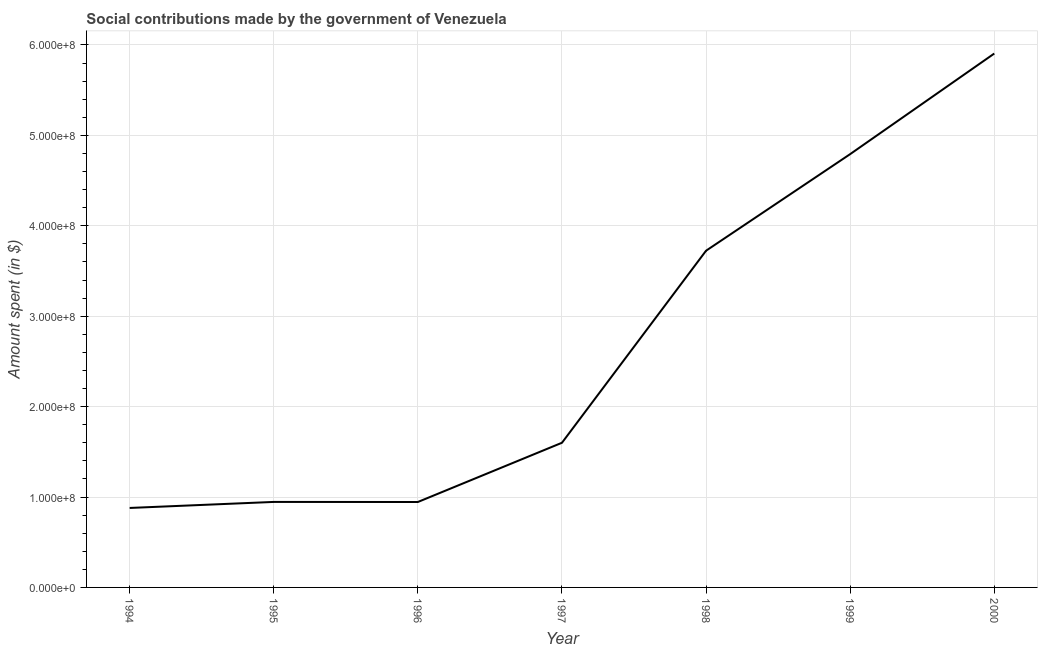What is the amount spent in making social contributions in 1998?
Offer a terse response. 3.72e+08. Across all years, what is the maximum amount spent in making social contributions?
Give a very brief answer. 5.91e+08. Across all years, what is the minimum amount spent in making social contributions?
Your answer should be compact. 8.79e+07. What is the sum of the amount spent in making social contributions?
Offer a very short reply. 1.88e+09. What is the difference between the amount spent in making social contributions in 1994 and 1998?
Give a very brief answer. -2.85e+08. What is the average amount spent in making social contributions per year?
Keep it short and to the point. 2.68e+08. What is the median amount spent in making social contributions?
Give a very brief answer. 1.60e+08. In how many years, is the amount spent in making social contributions greater than 100000000 $?
Your answer should be very brief. 4. Do a majority of the years between 1996 and 1997 (inclusive) have amount spent in making social contributions greater than 500000000 $?
Make the answer very short. No. What is the ratio of the amount spent in making social contributions in 1995 to that in 2000?
Give a very brief answer. 0.16. Is the difference between the amount spent in making social contributions in 1994 and 1996 greater than the difference between any two years?
Provide a succinct answer. No. What is the difference between the highest and the second highest amount spent in making social contributions?
Ensure brevity in your answer.  1.11e+08. What is the difference between the highest and the lowest amount spent in making social contributions?
Offer a very short reply. 5.03e+08. In how many years, is the amount spent in making social contributions greater than the average amount spent in making social contributions taken over all years?
Your response must be concise. 3. How many lines are there?
Your answer should be compact. 1. What is the difference between two consecutive major ticks on the Y-axis?
Offer a very short reply. 1.00e+08. Are the values on the major ticks of Y-axis written in scientific E-notation?
Give a very brief answer. Yes. What is the title of the graph?
Give a very brief answer. Social contributions made by the government of Venezuela. What is the label or title of the X-axis?
Give a very brief answer. Year. What is the label or title of the Y-axis?
Provide a succinct answer. Amount spent (in $). What is the Amount spent (in $) of 1994?
Give a very brief answer. 8.79e+07. What is the Amount spent (in $) of 1995?
Provide a succinct answer. 9.46e+07. What is the Amount spent (in $) of 1996?
Offer a very short reply. 9.45e+07. What is the Amount spent (in $) in 1997?
Offer a very short reply. 1.60e+08. What is the Amount spent (in $) of 1998?
Offer a very short reply. 3.72e+08. What is the Amount spent (in $) in 1999?
Your response must be concise. 4.79e+08. What is the Amount spent (in $) of 2000?
Your response must be concise. 5.91e+08. What is the difference between the Amount spent (in $) in 1994 and 1995?
Make the answer very short. -6.67e+06. What is the difference between the Amount spent (in $) in 1994 and 1996?
Your answer should be very brief. -6.58e+06. What is the difference between the Amount spent (in $) in 1994 and 1997?
Make the answer very short. -7.21e+07. What is the difference between the Amount spent (in $) in 1994 and 1998?
Your answer should be compact. -2.85e+08. What is the difference between the Amount spent (in $) in 1994 and 1999?
Your response must be concise. -3.91e+08. What is the difference between the Amount spent (in $) in 1994 and 2000?
Ensure brevity in your answer.  -5.03e+08. What is the difference between the Amount spent (in $) in 1995 and 1996?
Ensure brevity in your answer.  8.10e+04. What is the difference between the Amount spent (in $) in 1995 and 1997?
Ensure brevity in your answer.  -6.54e+07. What is the difference between the Amount spent (in $) in 1995 and 1998?
Your answer should be very brief. -2.78e+08. What is the difference between the Amount spent (in $) in 1995 and 1999?
Offer a terse response. -3.85e+08. What is the difference between the Amount spent (in $) in 1995 and 2000?
Your answer should be very brief. -4.96e+08. What is the difference between the Amount spent (in $) in 1996 and 1997?
Provide a short and direct response. -6.55e+07. What is the difference between the Amount spent (in $) in 1996 and 1998?
Your answer should be compact. -2.78e+08. What is the difference between the Amount spent (in $) in 1996 and 1999?
Keep it short and to the point. -3.85e+08. What is the difference between the Amount spent (in $) in 1996 and 2000?
Provide a short and direct response. -4.96e+08. What is the difference between the Amount spent (in $) in 1997 and 1998?
Offer a terse response. -2.12e+08. What is the difference between the Amount spent (in $) in 1997 and 1999?
Give a very brief answer. -3.19e+08. What is the difference between the Amount spent (in $) in 1997 and 2000?
Give a very brief answer. -4.30e+08. What is the difference between the Amount spent (in $) in 1998 and 1999?
Your answer should be compact. -1.07e+08. What is the difference between the Amount spent (in $) in 1998 and 2000?
Make the answer very short. -2.18e+08. What is the difference between the Amount spent (in $) in 1999 and 2000?
Provide a succinct answer. -1.11e+08. What is the ratio of the Amount spent (in $) in 1994 to that in 1995?
Your answer should be compact. 0.93. What is the ratio of the Amount spent (in $) in 1994 to that in 1996?
Ensure brevity in your answer.  0.93. What is the ratio of the Amount spent (in $) in 1994 to that in 1997?
Keep it short and to the point. 0.55. What is the ratio of the Amount spent (in $) in 1994 to that in 1998?
Provide a succinct answer. 0.24. What is the ratio of the Amount spent (in $) in 1994 to that in 1999?
Give a very brief answer. 0.18. What is the ratio of the Amount spent (in $) in 1994 to that in 2000?
Offer a very short reply. 0.15. What is the ratio of the Amount spent (in $) in 1995 to that in 1996?
Offer a terse response. 1. What is the ratio of the Amount spent (in $) in 1995 to that in 1997?
Provide a succinct answer. 0.59. What is the ratio of the Amount spent (in $) in 1995 to that in 1998?
Make the answer very short. 0.25. What is the ratio of the Amount spent (in $) in 1995 to that in 1999?
Provide a short and direct response. 0.2. What is the ratio of the Amount spent (in $) in 1995 to that in 2000?
Offer a very short reply. 0.16. What is the ratio of the Amount spent (in $) in 1996 to that in 1997?
Your answer should be compact. 0.59. What is the ratio of the Amount spent (in $) in 1996 to that in 1998?
Provide a succinct answer. 0.25. What is the ratio of the Amount spent (in $) in 1996 to that in 1999?
Your answer should be very brief. 0.2. What is the ratio of the Amount spent (in $) in 1996 to that in 2000?
Offer a very short reply. 0.16. What is the ratio of the Amount spent (in $) in 1997 to that in 1998?
Your answer should be very brief. 0.43. What is the ratio of the Amount spent (in $) in 1997 to that in 1999?
Ensure brevity in your answer.  0.33. What is the ratio of the Amount spent (in $) in 1997 to that in 2000?
Keep it short and to the point. 0.27. What is the ratio of the Amount spent (in $) in 1998 to that in 1999?
Give a very brief answer. 0.78. What is the ratio of the Amount spent (in $) in 1998 to that in 2000?
Provide a succinct answer. 0.63. What is the ratio of the Amount spent (in $) in 1999 to that in 2000?
Keep it short and to the point. 0.81. 